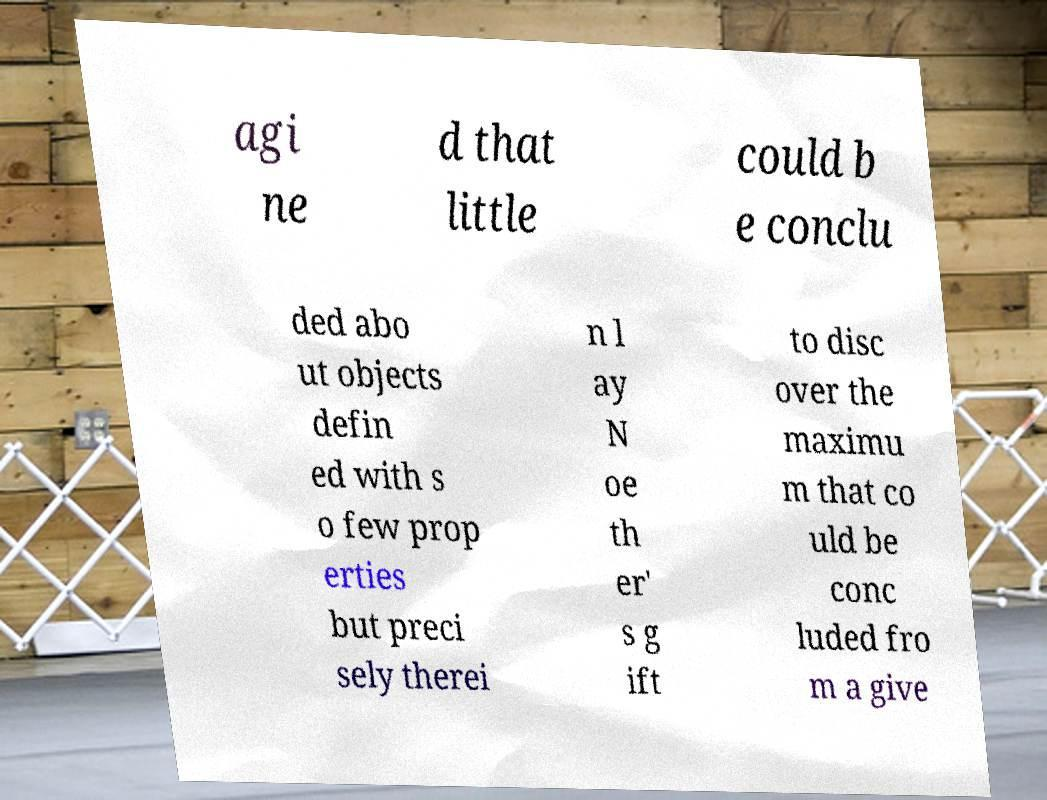I need the written content from this picture converted into text. Can you do that? agi ne d that little could b e conclu ded abo ut objects defin ed with s o few prop erties but preci sely therei n l ay N oe th er' s g ift to disc over the maximu m that co uld be conc luded fro m a give 